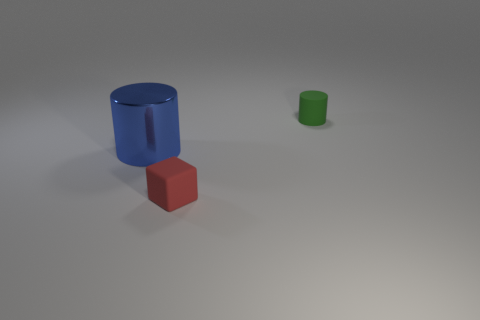Add 2 small purple shiny cylinders. How many objects exist? 5 Subtract all blocks. How many objects are left? 2 Add 1 tiny cyan cylinders. How many tiny cyan cylinders exist? 1 Subtract 0 purple balls. How many objects are left? 3 Subtract all big green metallic cylinders. Subtract all green rubber cylinders. How many objects are left? 2 Add 3 small green objects. How many small green objects are left? 4 